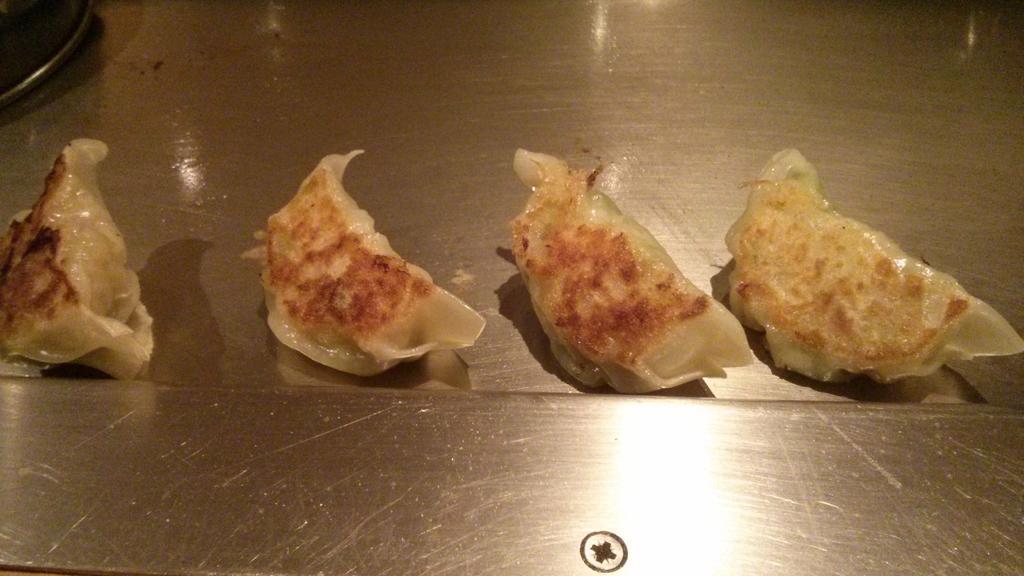Can you describe this image briefly? This image consist of food which is in the center. 